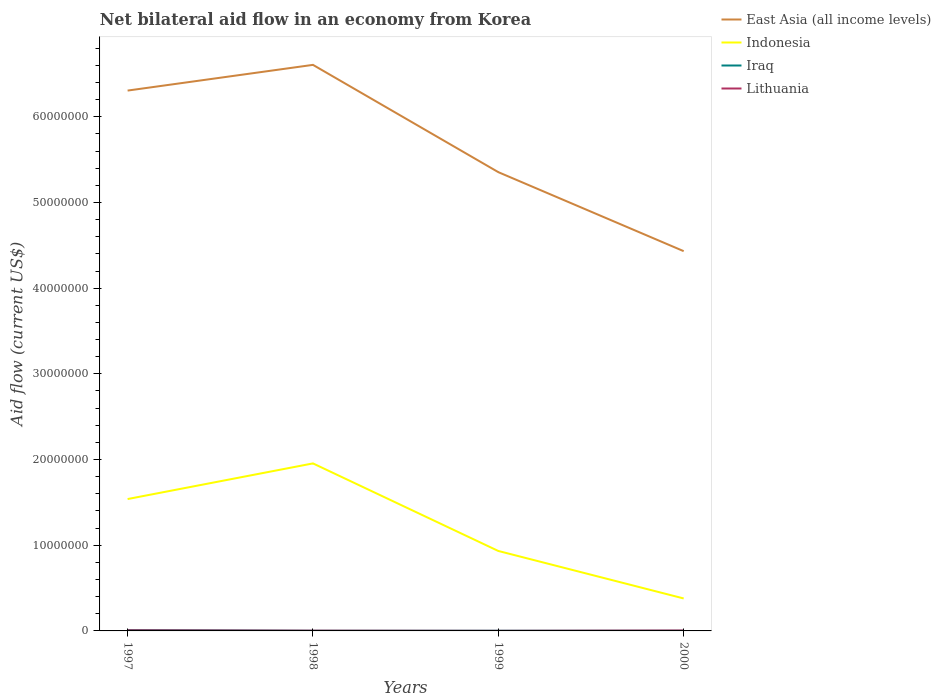How many different coloured lines are there?
Your response must be concise. 4. Does the line corresponding to Indonesia intersect with the line corresponding to Iraq?
Offer a terse response. No. Is the number of lines equal to the number of legend labels?
Your answer should be very brief. Yes. What is the total net bilateral aid flow in Indonesia in the graph?
Ensure brevity in your answer.  -4.16e+06. What is the difference between the highest and the second highest net bilateral aid flow in Lithuania?
Your answer should be very brief. 6.00e+04. How many years are there in the graph?
Provide a short and direct response. 4. Are the values on the major ticks of Y-axis written in scientific E-notation?
Give a very brief answer. No. Where does the legend appear in the graph?
Your answer should be very brief. Top right. What is the title of the graph?
Make the answer very short. Net bilateral aid flow in an economy from Korea. What is the label or title of the Y-axis?
Your answer should be very brief. Aid flow (current US$). What is the Aid flow (current US$) in East Asia (all income levels) in 1997?
Keep it short and to the point. 6.31e+07. What is the Aid flow (current US$) of Indonesia in 1997?
Your answer should be very brief. 1.54e+07. What is the Aid flow (current US$) of East Asia (all income levels) in 1998?
Ensure brevity in your answer.  6.61e+07. What is the Aid flow (current US$) of Indonesia in 1998?
Provide a succinct answer. 1.96e+07. What is the Aid flow (current US$) of Iraq in 1998?
Offer a very short reply. 2.00e+04. What is the Aid flow (current US$) of East Asia (all income levels) in 1999?
Offer a terse response. 5.35e+07. What is the Aid flow (current US$) in Indonesia in 1999?
Your answer should be compact. 9.33e+06. What is the Aid flow (current US$) of East Asia (all income levels) in 2000?
Ensure brevity in your answer.  4.43e+07. What is the Aid flow (current US$) of Indonesia in 2000?
Offer a terse response. 3.79e+06. What is the Aid flow (current US$) in Iraq in 2000?
Keep it short and to the point. 2.00e+04. Across all years, what is the maximum Aid flow (current US$) of East Asia (all income levels)?
Your answer should be compact. 6.61e+07. Across all years, what is the maximum Aid flow (current US$) in Indonesia?
Provide a short and direct response. 1.96e+07. Across all years, what is the maximum Aid flow (current US$) of Lithuania?
Provide a succinct answer. 7.00e+04. Across all years, what is the minimum Aid flow (current US$) in East Asia (all income levels)?
Make the answer very short. 4.43e+07. Across all years, what is the minimum Aid flow (current US$) of Indonesia?
Give a very brief answer. 3.79e+06. What is the total Aid flow (current US$) in East Asia (all income levels) in the graph?
Make the answer very short. 2.27e+08. What is the total Aid flow (current US$) in Indonesia in the graph?
Your response must be concise. 4.81e+07. What is the total Aid flow (current US$) of Iraq in the graph?
Keep it short and to the point. 1.60e+05. What is the total Aid flow (current US$) in Lithuania in the graph?
Offer a very short reply. 1.60e+05. What is the difference between the Aid flow (current US$) in Indonesia in 1997 and that in 1998?
Make the answer very short. -4.16e+06. What is the difference between the Aid flow (current US$) of Iraq in 1997 and that in 1998?
Give a very brief answer. 8.00e+04. What is the difference between the Aid flow (current US$) in East Asia (all income levels) in 1997 and that in 1999?
Provide a short and direct response. 9.52e+06. What is the difference between the Aid flow (current US$) in Indonesia in 1997 and that in 1999?
Keep it short and to the point. 6.06e+06. What is the difference between the Aid flow (current US$) in East Asia (all income levels) in 1997 and that in 2000?
Offer a very short reply. 1.87e+07. What is the difference between the Aid flow (current US$) of Indonesia in 1997 and that in 2000?
Offer a very short reply. 1.16e+07. What is the difference between the Aid flow (current US$) of Iraq in 1997 and that in 2000?
Make the answer very short. 8.00e+04. What is the difference between the Aid flow (current US$) in East Asia (all income levels) in 1998 and that in 1999?
Your response must be concise. 1.25e+07. What is the difference between the Aid flow (current US$) of Indonesia in 1998 and that in 1999?
Your answer should be compact. 1.02e+07. What is the difference between the Aid flow (current US$) in East Asia (all income levels) in 1998 and that in 2000?
Provide a succinct answer. 2.17e+07. What is the difference between the Aid flow (current US$) in Indonesia in 1998 and that in 2000?
Your answer should be compact. 1.58e+07. What is the difference between the Aid flow (current US$) of East Asia (all income levels) in 1999 and that in 2000?
Your response must be concise. 9.22e+06. What is the difference between the Aid flow (current US$) of Indonesia in 1999 and that in 2000?
Provide a short and direct response. 5.54e+06. What is the difference between the Aid flow (current US$) in East Asia (all income levels) in 1997 and the Aid flow (current US$) in Indonesia in 1998?
Offer a very short reply. 4.35e+07. What is the difference between the Aid flow (current US$) of East Asia (all income levels) in 1997 and the Aid flow (current US$) of Iraq in 1998?
Offer a terse response. 6.30e+07. What is the difference between the Aid flow (current US$) of East Asia (all income levels) in 1997 and the Aid flow (current US$) of Lithuania in 1998?
Keep it short and to the point. 6.30e+07. What is the difference between the Aid flow (current US$) of Indonesia in 1997 and the Aid flow (current US$) of Iraq in 1998?
Your response must be concise. 1.54e+07. What is the difference between the Aid flow (current US$) in Indonesia in 1997 and the Aid flow (current US$) in Lithuania in 1998?
Give a very brief answer. 1.54e+07. What is the difference between the Aid flow (current US$) of Iraq in 1997 and the Aid flow (current US$) of Lithuania in 1998?
Offer a very short reply. 7.00e+04. What is the difference between the Aid flow (current US$) of East Asia (all income levels) in 1997 and the Aid flow (current US$) of Indonesia in 1999?
Provide a succinct answer. 5.37e+07. What is the difference between the Aid flow (current US$) in East Asia (all income levels) in 1997 and the Aid flow (current US$) in Iraq in 1999?
Make the answer very short. 6.30e+07. What is the difference between the Aid flow (current US$) of East Asia (all income levels) in 1997 and the Aid flow (current US$) of Lithuania in 1999?
Ensure brevity in your answer.  6.30e+07. What is the difference between the Aid flow (current US$) of Indonesia in 1997 and the Aid flow (current US$) of Iraq in 1999?
Your answer should be very brief. 1.54e+07. What is the difference between the Aid flow (current US$) of Indonesia in 1997 and the Aid flow (current US$) of Lithuania in 1999?
Your answer should be compact. 1.54e+07. What is the difference between the Aid flow (current US$) in East Asia (all income levels) in 1997 and the Aid flow (current US$) in Indonesia in 2000?
Make the answer very short. 5.93e+07. What is the difference between the Aid flow (current US$) of East Asia (all income levels) in 1997 and the Aid flow (current US$) of Iraq in 2000?
Offer a very short reply. 6.30e+07. What is the difference between the Aid flow (current US$) of East Asia (all income levels) in 1997 and the Aid flow (current US$) of Lithuania in 2000?
Your answer should be very brief. 6.30e+07. What is the difference between the Aid flow (current US$) of Indonesia in 1997 and the Aid flow (current US$) of Iraq in 2000?
Ensure brevity in your answer.  1.54e+07. What is the difference between the Aid flow (current US$) in Indonesia in 1997 and the Aid flow (current US$) in Lithuania in 2000?
Provide a succinct answer. 1.53e+07. What is the difference between the Aid flow (current US$) of Iraq in 1997 and the Aid flow (current US$) of Lithuania in 2000?
Your answer should be compact. 5.00e+04. What is the difference between the Aid flow (current US$) in East Asia (all income levels) in 1998 and the Aid flow (current US$) in Indonesia in 1999?
Ensure brevity in your answer.  5.67e+07. What is the difference between the Aid flow (current US$) in East Asia (all income levels) in 1998 and the Aid flow (current US$) in Iraq in 1999?
Provide a succinct answer. 6.60e+07. What is the difference between the Aid flow (current US$) in East Asia (all income levels) in 1998 and the Aid flow (current US$) in Lithuania in 1999?
Provide a succinct answer. 6.60e+07. What is the difference between the Aid flow (current US$) in Indonesia in 1998 and the Aid flow (current US$) in Iraq in 1999?
Your answer should be very brief. 1.95e+07. What is the difference between the Aid flow (current US$) in Indonesia in 1998 and the Aid flow (current US$) in Lithuania in 1999?
Keep it short and to the point. 1.95e+07. What is the difference between the Aid flow (current US$) in Iraq in 1998 and the Aid flow (current US$) in Lithuania in 1999?
Offer a very short reply. 10000. What is the difference between the Aid flow (current US$) in East Asia (all income levels) in 1998 and the Aid flow (current US$) in Indonesia in 2000?
Your response must be concise. 6.23e+07. What is the difference between the Aid flow (current US$) of East Asia (all income levels) in 1998 and the Aid flow (current US$) of Iraq in 2000?
Your answer should be very brief. 6.60e+07. What is the difference between the Aid flow (current US$) of East Asia (all income levels) in 1998 and the Aid flow (current US$) of Lithuania in 2000?
Offer a terse response. 6.60e+07. What is the difference between the Aid flow (current US$) of Indonesia in 1998 and the Aid flow (current US$) of Iraq in 2000?
Keep it short and to the point. 1.95e+07. What is the difference between the Aid flow (current US$) of Indonesia in 1998 and the Aid flow (current US$) of Lithuania in 2000?
Ensure brevity in your answer.  1.95e+07. What is the difference between the Aid flow (current US$) of Iraq in 1998 and the Aid flow (current US$) of Lithuania in 2000?
Provide a succinct answer. -3.00e+04. What is the difference between the Aid flow (current US$) in East Asia (all income levels) in 1999 and the Aid flow (current US$) in Indonesia in 2000?
Provide a succinct answer. 4.98e+07. What is the difference between the Aid flow (current US$) in East Asia (all income levels) in 1999 and the Aid flow (current US$) in Iraq in 2000?
Your answer should be very brief. 5.35e+07. What is the difference between the Aid flow (current US$) of East Asia (all income levels) in 1999 and the Aid flow (current US$) of Lithuania in 2000?
Offer a very short reply. 5.35e+07. What is the difference between the Aid flow (current US$) of Indonesia in 1999 and the Aid flow (current US$) of Iraq in 2000?
Provide a succinct answer. 9.31e+06. What is the difference between the Aid flow (current US$) in Indonesia in 1999 and the Aid flow (current US$) in Lithuania in 2000?
Keep it short and to the point. 9.28e+06. What is the average Aid flow (current US$) in East Asia (all income levels) per year?
Your response must be concise. 5.67e+07. What is the average Aid flow (current US$) of Indonesia per year?
Provide a short and direct response. 1.20e+07. What is the average Aid flow (current US$) in Lithuania per year?
Your answer should be very brief. 4.00e+04. In the year 1997, what is the difference between the Aid flow (current US$) of East Asia (all income levels) and Aid flow (current US$) of Indonesia?
Provide a succinct answer. 4.77e+07. In the year 1997, what is the difference between the Aid flow (current US$) of East Asia (all income levels) and Aid flow (current US$) of Iraq?
Give a very brief answer. 6.30e+07. In the year 1997, what is the difference between the Aid flow (current US$) in East Asia (all income levels) and Aid flow (current US$) in Lithuania?
Offer a very short reply. 6.30e+07. In the year 1997, what is the difference between the Aid flow (current US$) in Indonesia and Aid flow (current US$) in Iraq?
Your response must be concise. 1.53e+07. In the year 1997, what is the difference between the Aid flow (current US$) of Indonesia and Aid flow (current US$) of Lithuania?
Make the answer very short. 1.53e+07. In the year 1997, what is the difference between the Aid flow (current US$) in Iraq and Aid flow (current US$) in Lithuania?
Keep it short and to the point. 3.00e+04. In the year 1998, what is the difference between the Aid flow (current US$) in East Asia (all income levels) and Aid flow (current US$) in Indonesia?
Give a very brief answer. 4.65e+07. In the year 1998, what is the difference between the Aid flow (current US$) of East Asia (all income levels) and Aid flow (current US$) of Iraq?
Offer a terse response. 6.60e+07. In the year 1998, what is the difference between the Aid flow (current US$) of East Asia (all income levels) and Aid flow (current US$) of Lithuania?
Your response must be concise. 6.60e+07. In the year 1998, what is the difference between the Aid flow (current US$) in Indonesia and Aid flow (current US$) in Iraq?
Ensure brevity in your answer.  1.95e+07. In the year 1998, what is the difference between the Aid flow (current US$) of Indonesia and Aid flow (current US$) of Lithuania?
Make the answer very short. 1.95e+07. In the year 1999, what is the difference between the Aid flow (current US$) in East Asia (all income levels) and Aid flow (current US$) in Indonesia?
Offer a terse response. 4.42e+07. In the year 1999, what is the difference between the Aid flow (current US$) in East Asia (all income levels) and Aid flow (current US$) in Iraq?
Provide a succinct answer. 5.35e+07. In the year 1999, what is the difference between the Aid flow (current US$) in East Asia (all income levels) and Aid flow (current US$) in Lithuania?
Offer a very short reply. 5.35e+07. In the year 1999, what is the difference between the Aid flow (current US$) of Indonesia and Aid flow (current US$) of Iraq?
Make the answer very short. 9.31e+06. In the year 1999, what is the difference between the Aid flow (current US$) in Indonesia and Aid flow (current US$) in Lithuania?
Your response must be concise. 9.32e+06. In the year 2000, what is the difference between the Aid flow (current US$) in East Asia (all income levels) and Aid flow (current US$) in Indonesia?
Your answer should be compact. 4.05e+07. In the year 2000, what is the difference between the Aid flow (current US$) in East Asia (all income levels) and Aid flow (current US$) in Iraq?
Your answer should be very brief. 4.43e+07. In the year 2000, what is the difference between the Aid flow (current US$) of East Asia (all income levels) and Aid flow (current US$) of Lithuania?
Offer a very short reply. 4.43e+07. In the year 2000, what is the difference between the Aid flow (current US$) of Indonesia and Aid flow (current US$) of Iraq?
Your answer should be very brief. 3.77e+06. In the year 2000, what is the difference between the Aid flow (current US$) in Indonesia and Aid flow (current US$) in Lithuania?
Keep it short and to the point. 3.74e+06. In the year 2000, what is the difference between the Aid flow (current US$) of Iraq and Aid flow (current US$) of Lithuania?
Keep it short and to the point. -3.00e+04. What is the ratio of the Aid flow (current US$) in East Asia (all income levels) in 1997 to that in 1998?
Your answer should be very brief. 0.95. What is the ratio of the Aid flow (current US$) in Indonesia in 1997 to that in 1998?
Offer a terse response. 0.79. What is the ratio of the Aid flow (current US$) of Lithuania in 1997 to that in 1998?
Your answer should be very brief. 2.33. What is the ratio of the Aid flow (current US$) in East Asia (all income levels) in 1997 to that in 1999?
Make the answer very short. 1.18. What is the ratio of the Aid flow (current US$) in Indonesia in 1997 to that in 1999?
Ensure brevity in your answer.  1.65. What is the ratio of the Aid flow (current US$) in East Asia (all income levels) in 1997 to that in 2000?
Keep it short and to the point. 1.42. What is the ratio of the Aid flow (current US$) of Indonesia in 1997 to that in 2000?
Provide a succinct answer. 4.06. What is the ratio of the Aid flow (current US$) of Iraq in 1997 to that in 2000?
Ensure brevity in your answer.  5. What is the ratio of the Aid flow (current US$) in East Asia (all income levels) in 1998 to that in 1999?
Offer a terse response. 1.23. What is the ratio of the Aid flow (current US$) in Indonesia in 1998 to that in 1999?
Provide a succinct answer. 2.1. What is the ratio of the Aid flow (current US$) in Lithuania in 1998 to that in 1999?
Your answer should be very brief. 3. What is the ratio of the Aid flow (current US$) in East Asia (all income levels) in 1998 to that in 2000?
Your answer should be compact. 1.49. What is the ratio of the Aid flow (current US$) in Indonesia in 1998 to that in 2000?
Your answer should be very brief. 5.16. What is the ratio of the Aid flow (current US$) in Iraq in 1998 to that in 2000?
Your response must be concise. 1. What is the ratio of the Aid flow (current US$) of East Asia (all income levels) in 1999 to that in 2000?
Offer a very short reply. 1.21. What is the ratio of the Aid flow (current US$) in Indonesia in 1999 to that in 2000?
Make the answer very short. 2.46. What is the ratio of the Aid flow (current US$) in Iraq in 1999 to that in 2000?
Give a very brief answer. 1. What is the difference between the highest and the second highest Aid flow (current US$) in East Asia (all income levels)?
Make the answer very short. 3.00e+06. What is the difference between the highest and the second highest Aid flow (current US$) in Indonesia?
Provide a succinct answer. 4.16e+06. What is the difference between the highest and the second highest Aid flow (current US$) in Iraq?
Offer a very short reply. 8.00e+04. What is the difference between the highest and the lowest Aid flow (current US$) of East Asia (all income levels)?
Provide a succinct answer. 2.17e+07. What is the difference between the highest and the lowest Aid flow (current US$) in Indonesia?
Your answer should be very brief. 1.58e+07. What is the difference between the highest and the lowest Aid flow (current US$) of Iraq?
Your answer should be compact. 8.00e+04. What is the difference between the highest and the lowest Aid flow (current US$) of Lithuania?
Keep it short and to the point. 6.00e+04. 